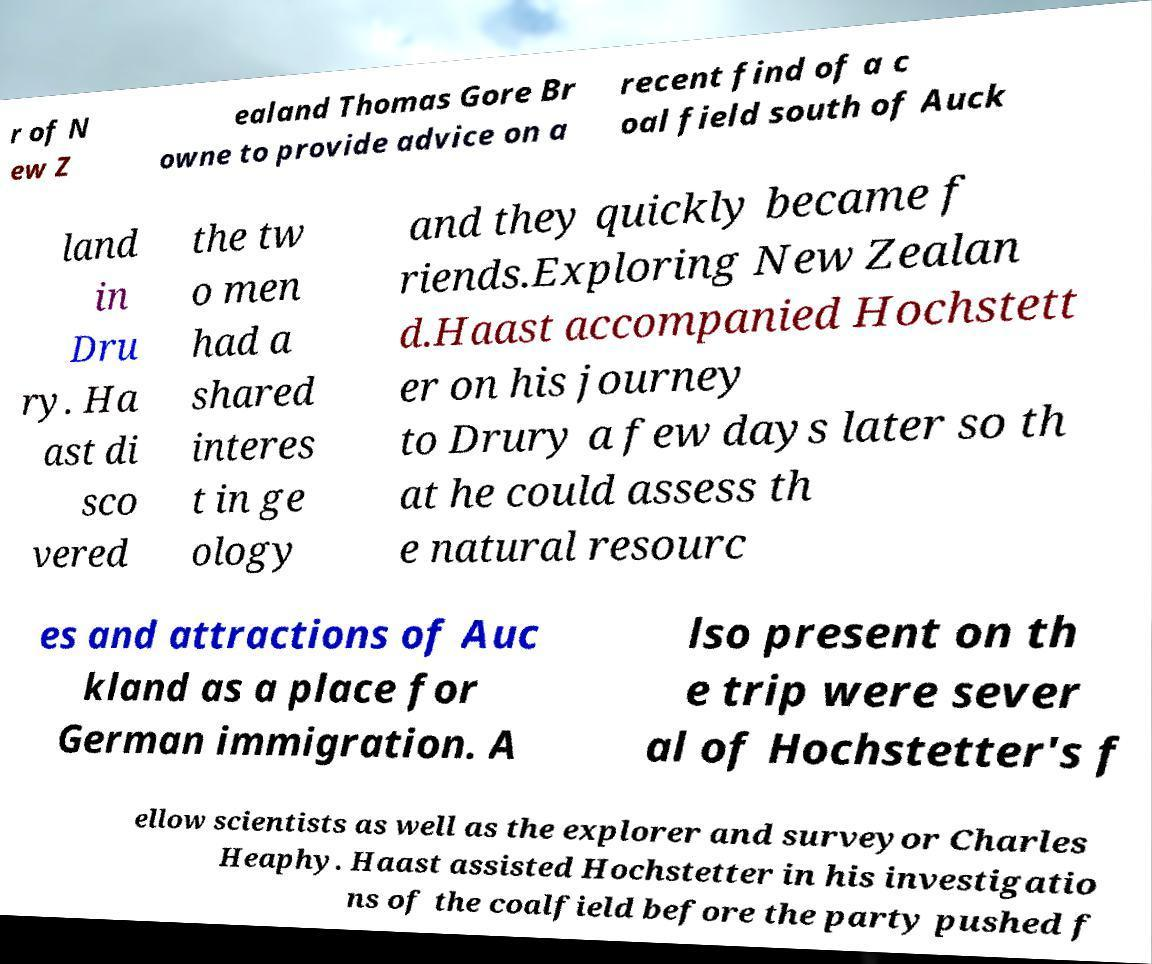Can you accurately transcribe the text from the provided image for me? r of N ew Z ealand Thomas Gore Br owne to provide advice on a recent find of a c oal field south of Auck land in Dru ry. Ha ast di sco vered the tw o men had a shared interes t in ge ology and they quickly became f riends.Exploring New Zealan d.Haast accompanied Hochstett er on his journey to Drury a few days later so th at he could assess th e natural resourc es and attractions of Auc kland as a place for German immigration. A lso present on th e trip were sever al of Hochstetter's f ellow scientists as well as the explorer and surveyor Charles Heaphy. Haast assisted Hochstetter in his investigatio ns of the coalfield before the party pushed f 